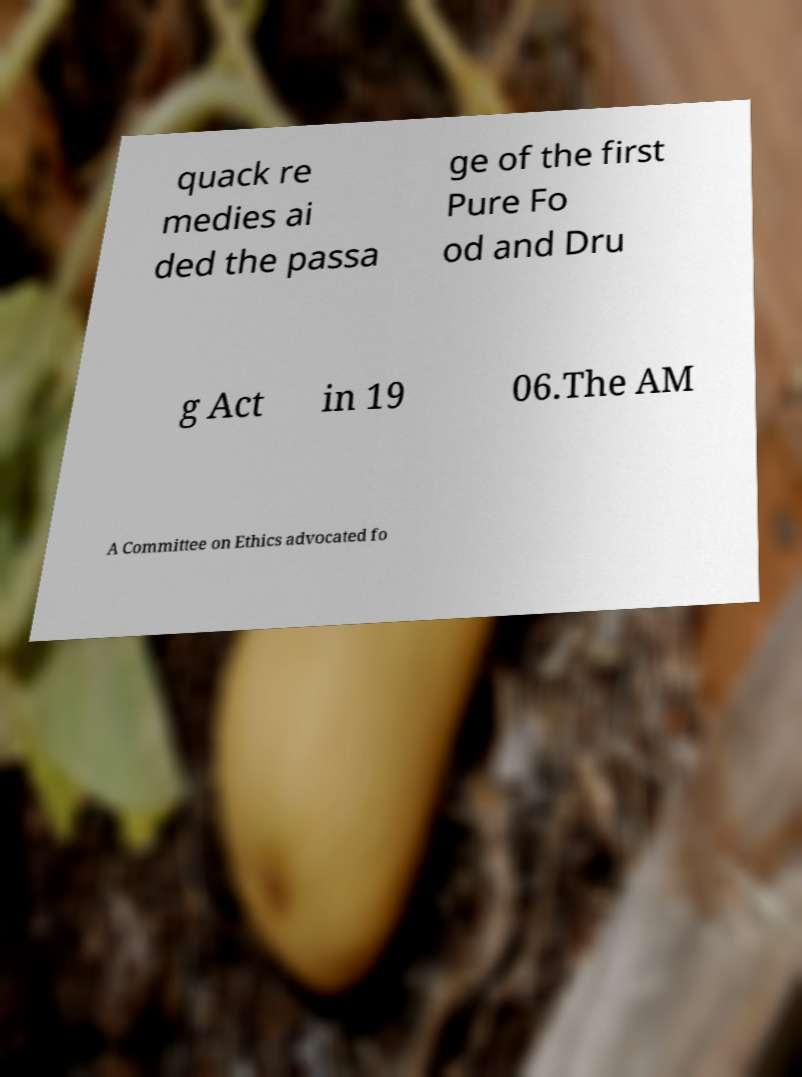What messages or text are displayed in this image? I need them in a readable, typed format. quack re medies ai ded the passa ge of the first Pure Fo od and Dru g Act in 19 06.The AM A Committee on Ethics advocated fo 